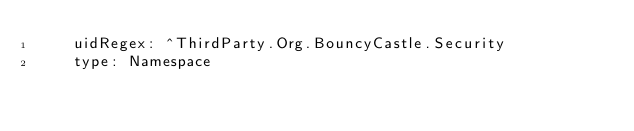Convert code to text. <code><loc_0><loc_0><loc_500><loc_500><_YAML_>    uidRegex: ^ThirdParty.Org.BouncyCastle.Security
    type: Namespace</code> 